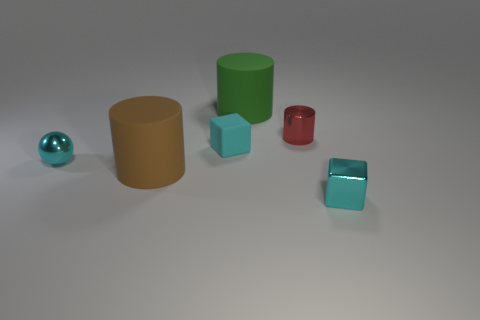Subtract all matte cylinders. How many cylinders are left? 1 Add 3 green matte cylinders. How many objects exist? 9 Subtract all blocks. How many objects are left? 4 Add 4 tiny red objects. How many tiny red objects are left? 5 Add 1 shiny blocks. How many shiny blocks exist? 2 Subtract 0 purple cubes. How many objects are left? 6 Subtract all red cylinders. Subtract all purple spheres. How many cylinders are left? 2 Subtract all blue cylinders. Subtract all big green rubber objects. How many objects are left? 5 